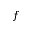Convert formula to latex. <formula><loc_0><loc_0><loc_500><loc_500>f</formula> 